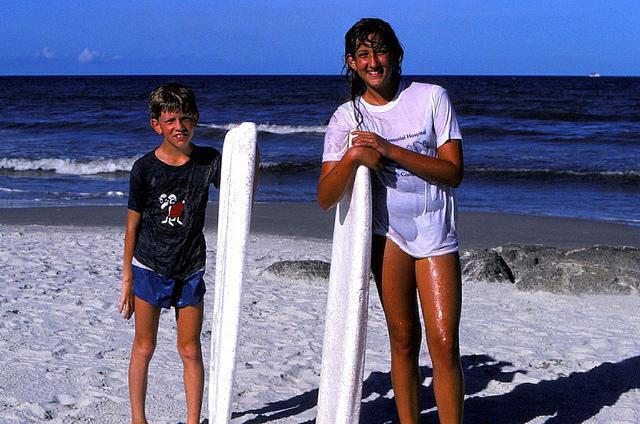How do these people know each other?
Choose the correct response, then elucidate: 'Answer: answer
Rationale: rationale.'
Options: Coworkers, teammates, siblings, rivals. Answer: siblings.
Rationale: These kids are siblings. 